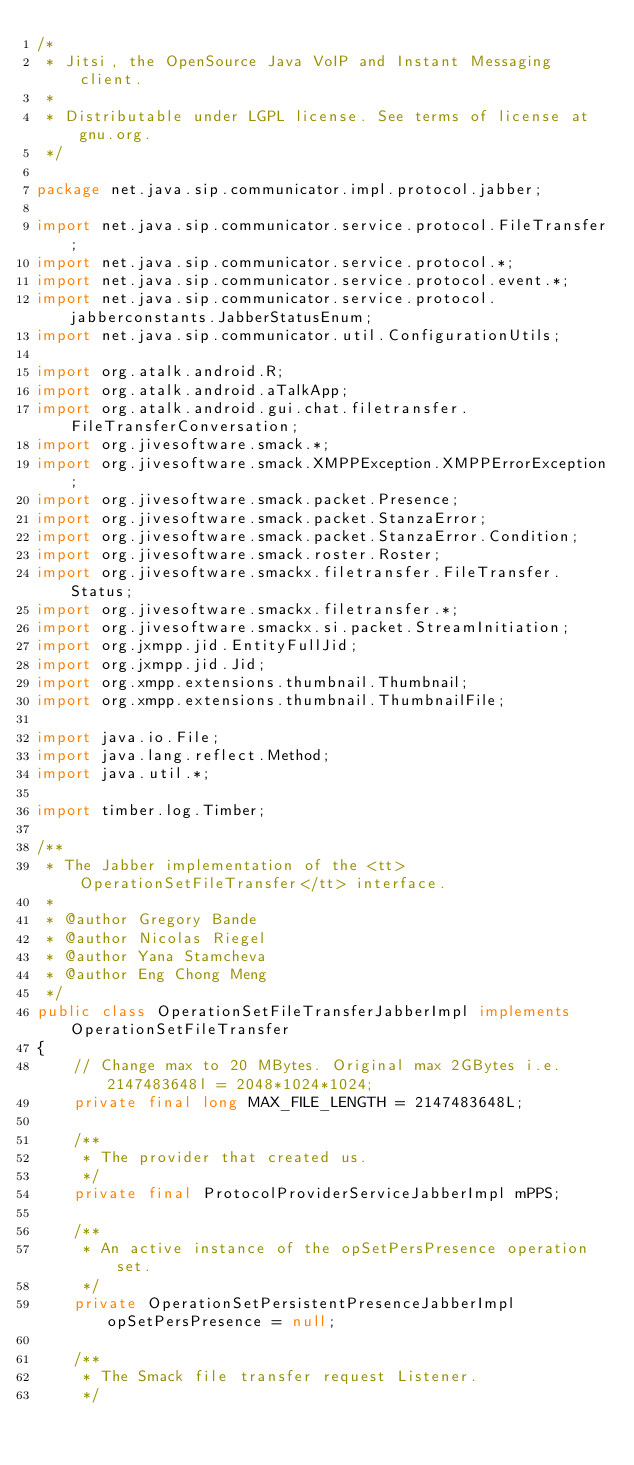<code> <loc_0><loc_0><loc_500><loc_500><_Java_>/*
 * Jitsi, the OpenSource Java VoIP and Instant Messaging client.
 *
 * Distributable under LGPL license. See terms of license at gnu.org.
 */

package net.java.sip.communicator.impl.protocol.jabber;

import net.java.sip.communicator.service.protocol.FileTransfer;
import net.java.sip.communicator.service.protocol.*;
import net.java.sip.communicator.service.protocol.event.*;
import net.java.sip.communicator.service.protocol.jabberconstants.JabberStatusEnum;
import net.java.sip.communicator.util.ConfigurationUtils;

import org.atalk.android.R;
import org.atalk.android.aTalkApp;
import org.atalk.android.gui.chat.filetransfer.FileTransferConversation;
import org.jivesoftware.smack.*;
import org.jivesoftware.smack.XMPPException.XMPPErrorException;
import org.jivesoftware.smack.packet.Presence;
import org.jivesoftware.smack.packet.StanzaError;
import org.jivesoftware.smack.packet.StanzaError.Condition;
import org.jivesoftware.smack.roster.Roster;
import org.jivesoftware.smackx.filetransfer.FileTransfer.Status;
import org.jivesoftware.smackx.filetransfer.*;
import org.jivesoftware.smackx.si.packet.StreamInitiation;
import org.jxmpp.jid.EntityFullJid;
import org.jxmpp.jid.Jid;
import org.xmpp.extensions.thumbnail.Thumbnail;
import org.xmpp.extensions.thumbnail.ThumbnailFile;

import java.io.File;
import java.lang.reflect.Method;
import java.util.*;

import timber.log.Timber;

/**
 * The Jabber implementation of the <tt>OperationSetFileTransfer</tt> interface.
 *
 * @author Gregory Bande
 * @author Nicolas Riegel
 * @author Yana Stamcheva
 * @author Eng Chong Meng
 */
public class OperationSetFileTransferJabberImpl implements OperationSetFileTransfer
{
    // Change max to 20 MBytes. Original max 2GBytes i.e. 2147483648l = 2048*1024*1024;
    private final long MAX_FILE_LENGTH = 2147483648L;

    /**
     * The provider that created us.
     */
    private final ProtocolProviderServiceJabberImpl mPPS;

    /**
     * An active instance of the opSetPersPresence operation set.
     */
    private OperationSetPersistentPresenceJabberImpl opSetPersPresence = null;

    /**
     * The Smack file transfer request Listener.
     */</code> 